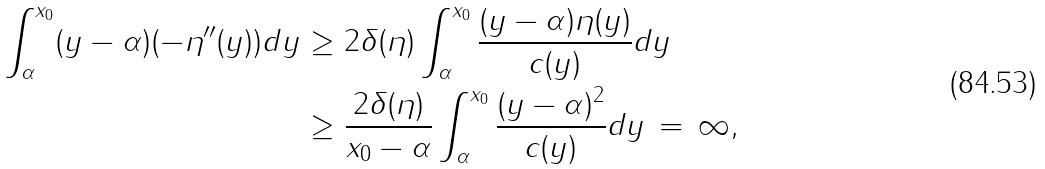<formula> <loc_0><loc_0><loc_500><loc_500>\int _ { \alpha } ^ { x _ { 0 } } ( y - \alpha ) ( - \eta ^ { \prime \prime } ( y ) ) d y & \geq 2 \delta ( \eta ) \int _ { \alpha } ^ { x _ { 0 } } \frac { ( y - \alpha ) \eta ( y ) } { c ( y ) } d y \\ & \geq \frac { 2 \delta ( \eta ) } { x _ { 0 } - \alpha } \int _ { \alpha } ^ { x _ { 0 } } \frac { ( y - \alpha ) ^ { 2 } } { c ( y ) } d y \, = \, \infty ,</formula> 